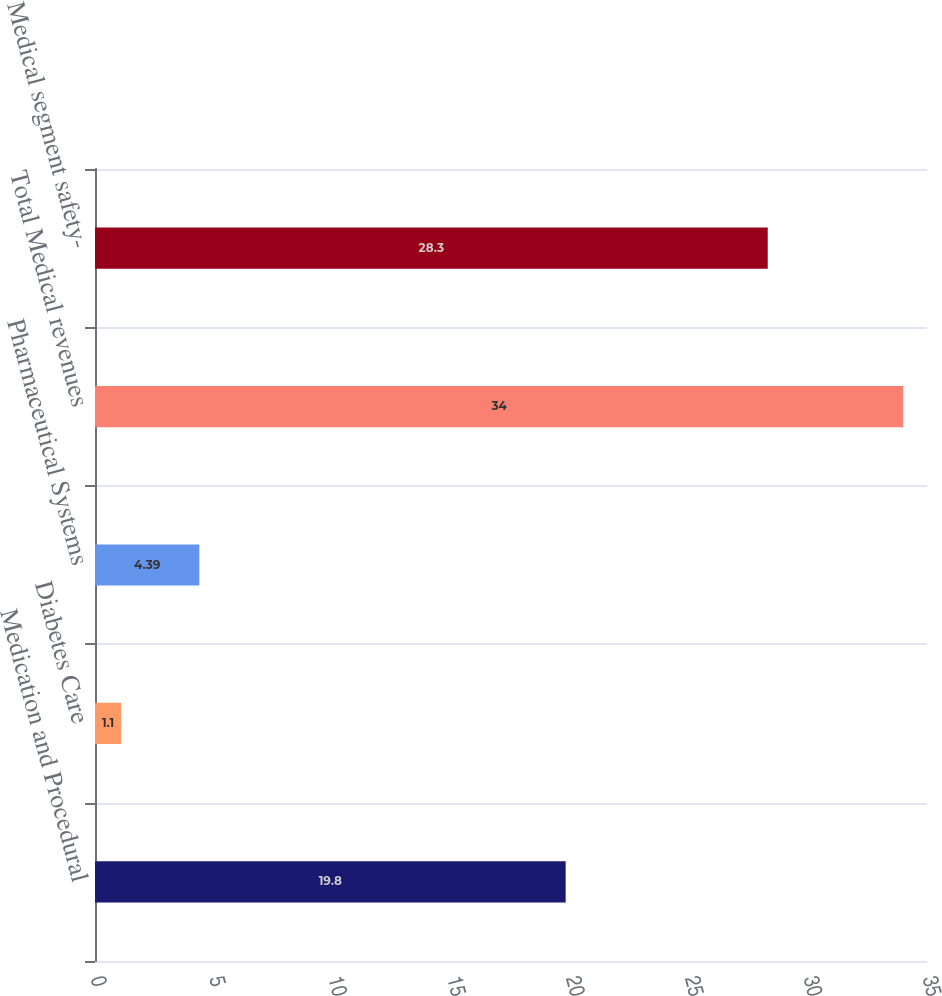<chart> <loc_0><loc_0><loc_500><loc_500><bar_chart><fcel>Medication and Procedural<fcel>Diabetes Care<fcel>Pharmaceutical Systems<fcel>Total Medical revenues<fcel>Medical segment safety-<nl><fcel>19.8<fcel>1.1<fcel>4.39<fcel>34<fcel>28.3<nl></chart> 